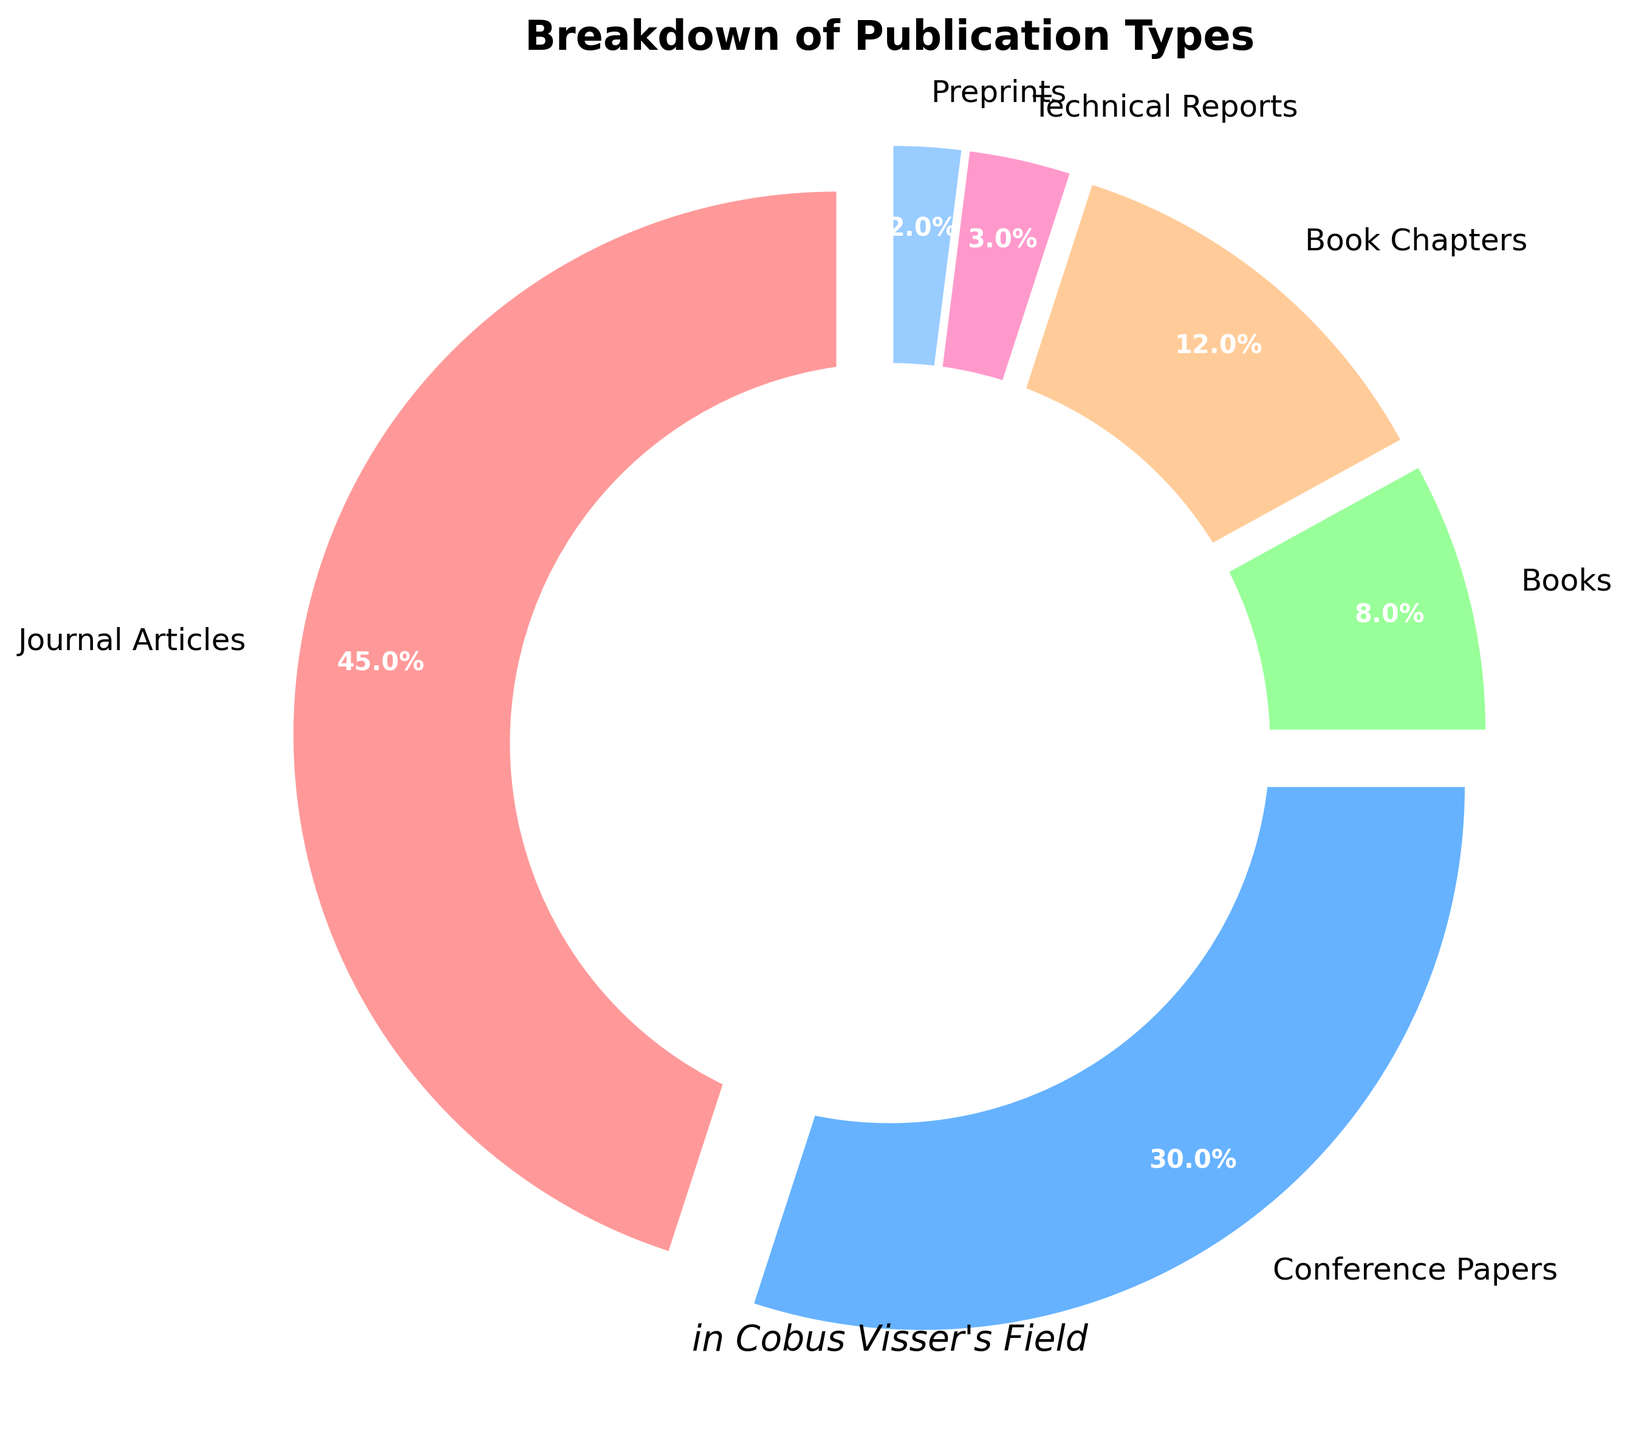What percentage of publications are conference papers? The pie chart shows the breakdown of publication types. The label for conference papers indicates 30%.
Answer: 30% What is the percentage difference between journal articles and books? The percentage for journal articles is 45% and for books is 8%. The difference is 45% - 8%.
Answer: 37% Are book chapters more or less common than technical reports? The percentage for book chapters is 12% and for technical reports, it's 3%. 12% is greater than 3%.
Answer: More common Which publication type has the smallest percentage? Among the publication types shown in the pie chart, preprints have the smallest percentage, indicated as 2%.
Answer: Preprints What is the combined percentage of book chapters, technical reports, and preprints? The pie chart shows 12% for book chapters, 3% for technical reports, and 2% for preprints. Adding these together gives 12% + 3% + 2%.
Answer: 17% Which publication type is represented by the green section of the pie chart? The green section can be identified from the pie chart's color legend, and it represents conference papers.
Answer: Conference papers What is the most common type of publication? The pie chart's largest section represents journal articles, indicating it as the most common type.
Answer: Journal articles How much more common are journal articles than conference papers? The percentage for journal articles is 45% and for conference papers is 30%. The difference is 45% - 30%.
Answer: 15% What is the percentage of publication types other than journal articles and conference papers? Journal articles are 45% and conference papers are 30%. The total of other types is 100% - (45% + 30%).
Answer: 25% How is the pie chart visually divided to highlight the different publication types? The pie chart uses different colors and an "exploded" effect, where each wedge is slightly separated from the center, to highlight different publication types.
Answer: Different colors and exploded effect 